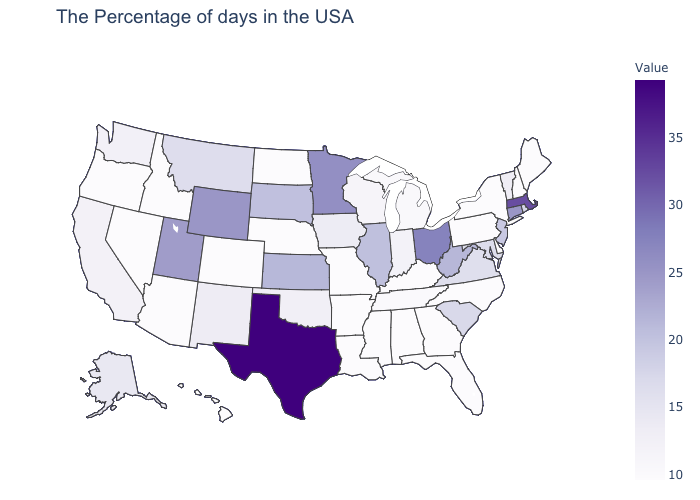Among the states that border Tennessee , which have the lowest value?
Give a very brief answer. North Carolina, Georgia, Kentucky, Alabama, Mississippi, Missouri. Among the states that border Georgia , which have the lowest value?
Write a very short answer. North Carolina, Florida, Alabama. Does Wisconsin have the lowest value in the MidWest?
Answer briefly. No. Among the states that border Oklahoma , which have the highest value?
Answer briefly. Texas. Which states hav the highest value in the MidWest?
Give a very brief answer. Ohio. 